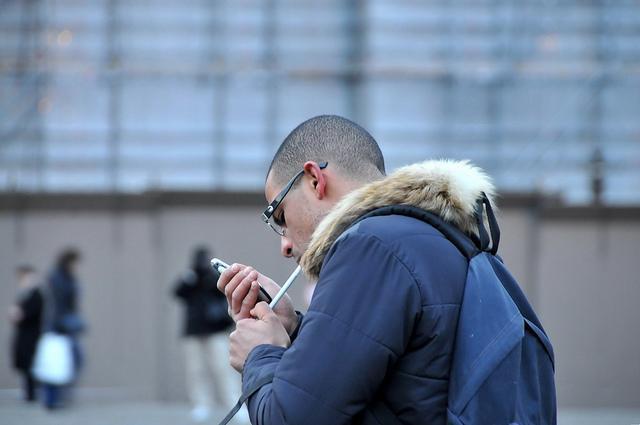How many people are visible?
Give a very brief answer. 4. 